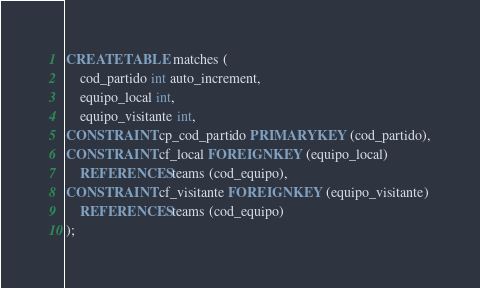Convert code to text. <code><loc_0><loc_0><loc_500><loc_500><_SQL_>CREATE TABLE matches (
	cod_partido int auto_increment,
	equipo_local int,
	equipo_visitante int,
CONSTRAINT cp_cod_partido PRIMARY KEY (cod_partido),
CONSTRAINT cf_local FOREIGN KEY (equipo_local)
	REFERENCES teams (cod_equipo),
CONSTRAINT cf_visitante FOREIGN KEY (equipo_visitante)
	REFERENCES teams (cod_equipo)
);

</code> 